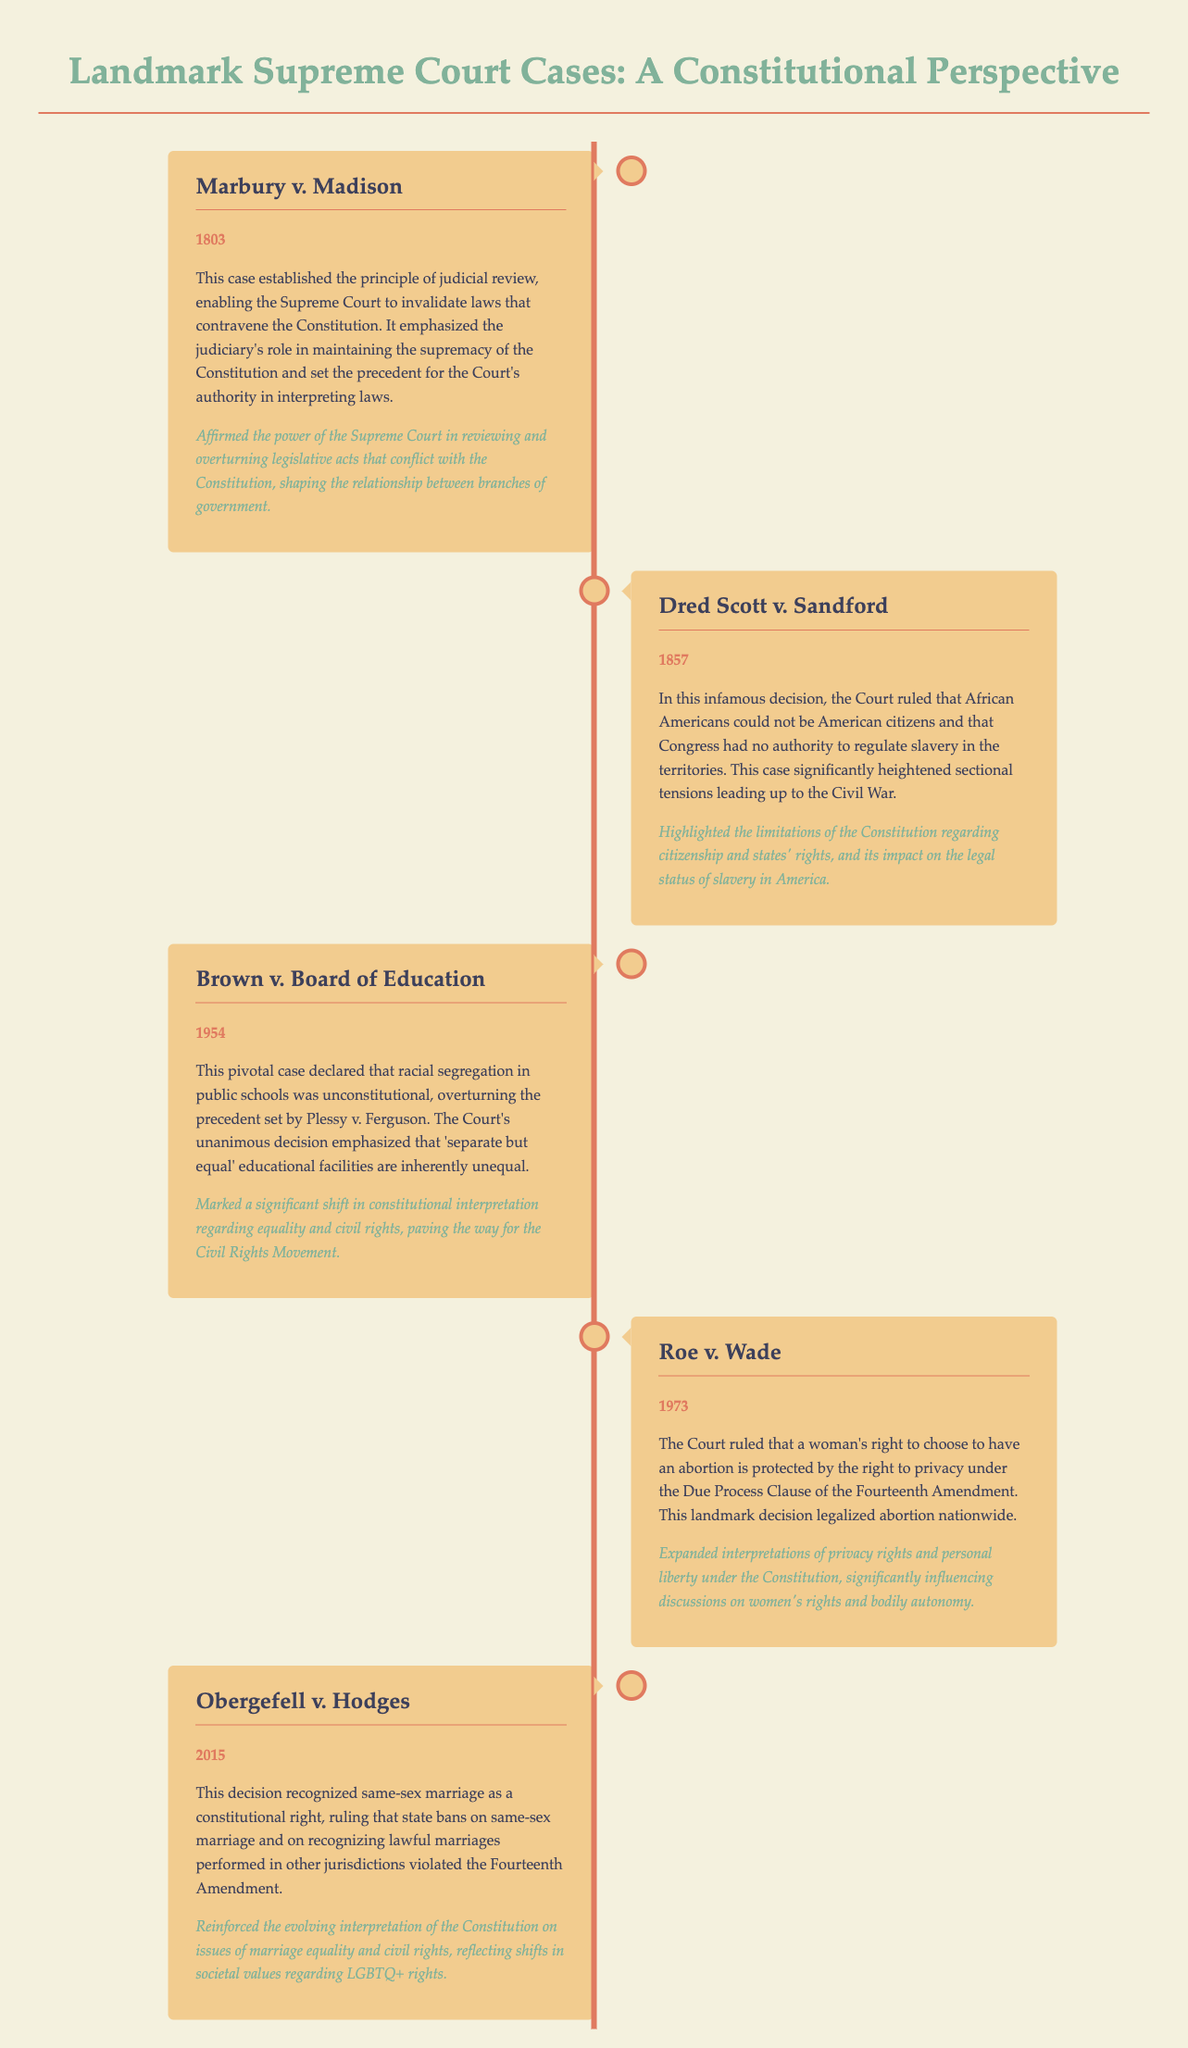What year was Marbury v. Madison decided? The case of Marbury v. Madison was decided in the year mentioned in the document, which is 1803.
Answer: 1803 What was the key principle established in Marbury v. Madison? The document states that Marbury v. Madison established the principle of judicial review, which is a key focus of this case.
Answer: Judicial review What did the Dred Scott v. Sandford ruling affirm about citizenship? The document indicates that Dred Scott v. Sandford ruled that African Americans could not be American citizens, which directly answers the question.
Answer: Not citizens In what case was racial segregation in public schools declared unconstitutional? The document specifies that Brown v. Board of Education is the case in which racial segregation in public schools was declared unconstitutional.
Answer: Brown v. Board of Education What did the Supreme Court conclude regarding abortion in Roe v. Wade? According to the document, Roe v. Wade concluded that a woman's right to choose to have an abortion is protected by the right to privacy.
Answer: Right to privacy Which amendment was central to the ruling in Obergefell v. Hodges? The Fourteenth Amendment is highlighted in the document as central to the ruling in Obergefell v. Hodges.
Answer: Fourteenth Amendment How many landmark cases are presented in the document? The document lists five landmark cases in total.
Answer: Five What does the summary of Brown v. Board of Education emphasize about educational facilities? The summary indicates that the decision emphasized that 'separate but equal' educational facilities are inherently unequal.
Answer: Inherently unequal Why is the significance of Roe v. Wade described as impactful? The document describes the significance of Roe v. Wade as expanding interpretations of privacy rights and influencing discussions on women's rights, highlighting its impact.
Answer: Women's rights and bodily autonomy 